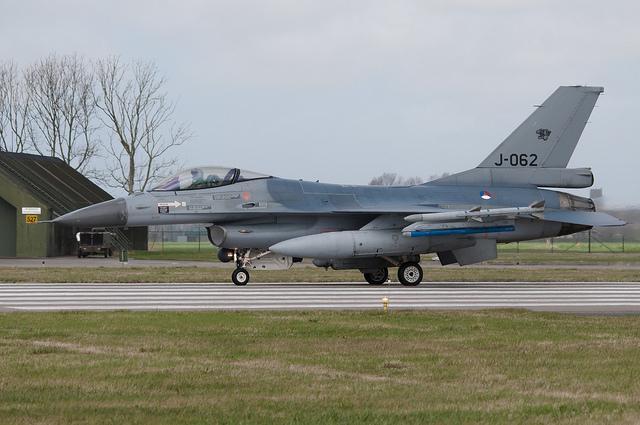How many wheels are on the ground?
Give a very brief answer. 3. How many hot dogs are on the plate?
Give a very brief answer. 0. 